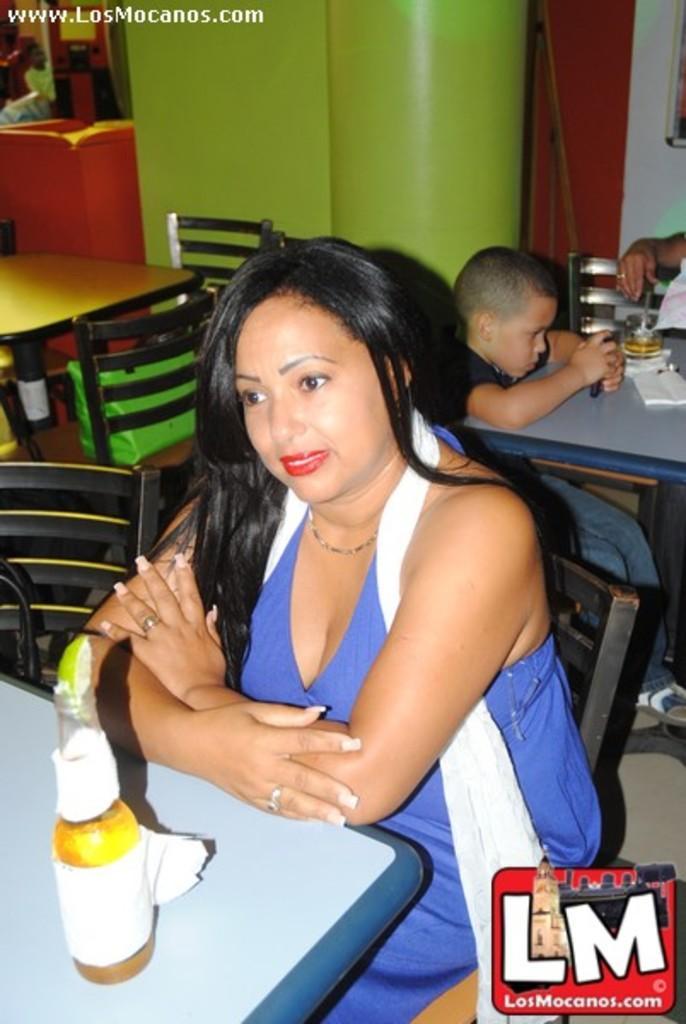How would you summarize this image in a sentence or two? In this picture we can see a bottle and a few objects on the tables. We can see a woman and a boy sitting on the chair. There is the hand of a person. We can see a few objects and a person in the background. A text is visible in the top left and a watermark is visible in the bottom right. 